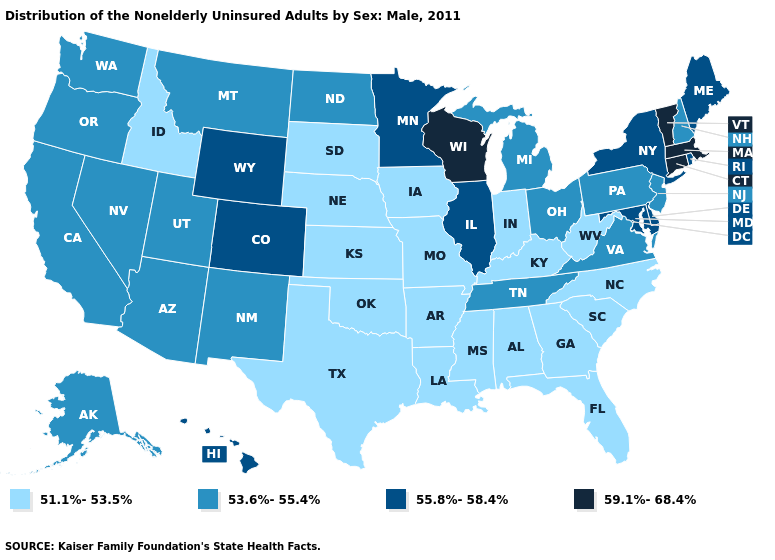What is the value of Montana?
Keep it brief. 53.6%-55.4%. Among the states that border Georgia , does Tennessee have the highest value?
Quick response, please. Yes. Name the states that have a value in the range 51.1%-53.5%?
Short answer required. Alabama, Arkansas, Florida, Georgia, Idaho, Indiana, Iowa, Kansas, Kentucky, Louisiana, Mississippi, Missouri, Nebraska, North Carolina, Oklahoma, South Carolina, South Dakota, Texas, West Virginia. What is the highest value in the USA?
Quick response, please. 59.1%-68.4%. Is the legend a continuous bar?
Quick response, please. No. Name the states that have a value in the range 51.1%-53.5%?
Give a very brief answer. Alabama, Arkansas, Florida, Georgia, Idaho, Indiana, Iowa, Kansas, Kentucky, Louisiana, Mississippi, Missouri, Nebraska, North Carolina, Oklahoma, South Carolina, South Dakota, Texas, West Virginia. Which states have the lowest value in the USA?
Short answer required. Alabama, Arkansas, Florida, Georgia, Idaho, Indiana, Iowa, Kansas, Kentucky, Louisiana, Mississippi, Missouri, Nebraska, North Carolina, Oklahoma, South Carolina, South Dakota, Texas, West Virginia. What is the value of Kansas?
Answer briefly. 51.1%-53.5%. Does Hawaii have the lowest value in the West?
Concise answer only. No. What is the value of Arkansas?
Answer briefly. 51.1%-53.5%. How many symbols are there in the legend?
Short answer required. 4. Name the states that have a value in the range 55.8%-58.4%?
Be succinct. Colorado, Delaware, Hawaii, Illinois, Maine, Maryland, Minnesota, New York, Rhode Island, Wyoming. Does Florida have the same value as Connecticut?
Write a very short answer. No. Does Maryland have a higher value than Illinois?
Short answer required. No. Name the states that have a value in the range 59.1%-68.4%?
Concise answer only. Connecticut, Massachusetts, Vermont, Wisconsin. 